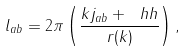<formula> <loc_0><loc_0><loc_500><loc_500>l _ { a b } = 2 \pi \left ( \frac { k j _ { a b } + \ h h } { r ( k ) } \right ) ,</formula> 